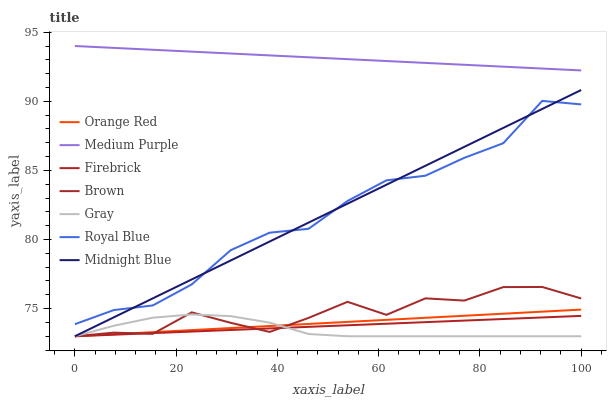Does Gray have the minimum area under the curve?
Answer yes or no. Yes. Does Medium Purple have the maximum area under the curve?
Answer yes or no. Yes. Does Midnight Blue have the minimum area under the curve?
Answer yes or no. No. Does Midnight Blue have the maximum area under the curve?
Answer yes or no. No. Is Orange Red the smoothest?
Answer yes or no. Yes. Is Royal Blue the roughest?
Answer yes or no. Yes. Is Midnight Blue the smoothest?
Answer yes or no. No. Is Midnight Blue the roughest?
Answer yes or no. No. Does Brown have the lowest value?
Answer yes or no. Yes. Does Medium Purple have the lowest value?
Answer yes or no. No. Does Medium Purple have the highest value?
Answer yes or no. Yes. Does Midnight Blue have the highest value?
Answer yes or no. No. Is Firebrick less than Medium Purple?
Answer yes or no. Yes. Is Medium Purple greater than Midnight Blue?
Answer yes or no. Yes. Does Firebrick intersect Brown?
Answer yes or no. Yes. Is Firebrick less than Brown?
Answer yes or no. No. Is Firebrick greater than Brown?
Answer yes or no. No. Does Firebrick intersect Medium Purple?
Answer yes or no. No. 